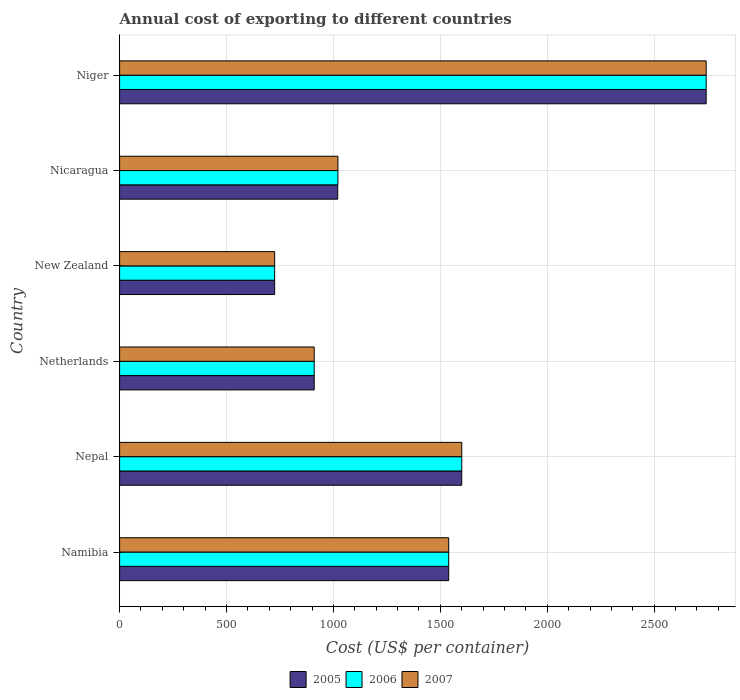How many groups of bars are there?
Your answer should be compact. 6. Are the number of bars per tick equal to the number of legend labels?
Keep it short and to the point. Yes. Are the number of bars on each tick of the Y-axis equal?
Offer a terse response. Yes. How many bars are there on the 4th tick from the bottom?
Offer a terse response. 3. What is the label of the 6th group of bars from the top?
Your answer should be very brief. Namibia. In how many cases, is the number of bars for a given country not equal to the number of legend labels?
Provide a succinct answer. 0. What is the total annual cost of exporting in 2006 in New Zealand?
Ensure brevity in your answer.  725. Across all countries, what is the maximum total annual cost of exporting in 2007?
Your answer should be compact. 2743. Across all countries, what is the minimum total annual cost of exporting in 2005?
Provide a succinct answer. 725. In which country was the total annual cost of exporting in 2006 maximum?
Offer a terse response. Niger. In which country was the total annual cost of exporting in 2007 minimum?
Your answer should be very brief. New Zealand. What is the total total annual cost of exporting in 2005 in the graph?
Give a very brief answer. 8537. What is the difference between the total annual cost of exporting in 2005 in Nepal and that in Nicaragua?
Your response must be concise. 580. What is the difference between the total annual cost of exporting in 2005 in Namibia and the total annual cost of exporting in 2007 in Niger?
Provide a short and direct response. -1204. What is the average total annual cost of exporting in 2005 per country?
Your answer should be very brief. 1422.83. What is the difference between the total annual cost of exporting in 2006 and total annual cost of exporting in 2007 in Nicaragua?
Your answer should be compact. 0. What is the ratio of the total annual cost of exporting in 2005 in New Zealand to that in Nicaragua?
Make the answer very short. 0.71. Is the total annual cost of exporting in 2007 in Nepal less than that in Netherlands?
Keep it short and to the point. No. Is the difference between the total annual cost of exporting in 2006 in Netherlands and Nicaragua greater than the difference between the total annual cost of exporting in 2007 in Netherlands and Nicaragua?
Your answer should be compact. No. What is the difference between the highest and the second highest total annual cost of exporting in 2006?
Keep it short and to the point. 1143. What is the difference between the highest and the lowest total annual cost of exporting in 2006?
Provide a succinct answer. 2018. In how many countries, is the total annual cost of exporting in 2005 greater than the average total annual cost of exporting in 2005 taken over all countries?
Keep it short and to the point. 3. What does the 3rd bar from the bottom in Niger represents?
Make the answer very short. 2007. Is it the case that in every country, the sum of the total annual cost of exporting in 2007 and total annual cost of exporting in 2005 is greater than the total annual cost of exporting in 2006?
Provide a short and direct response. Yes. How many bars are there?
Keep it short and to the point. 18. How many countries are there in the graph?
Give a very brief answer. 6. What is the difference between two consecutive major ticks on the X-axis?
Your answer should be very brief. 500. Does the graph contain any zero values?
Give a very brief answer. No. Where does the legend appear in the graph?
Make the answer very short. Bottom center. What is the title of the graph?
Make the answer very short. Annual cost of exporting to different countries. What is the label or title of the X-axis?
Offer a very short reply. Cost (US$ per container). What is the label or title of the Y-axis?
Ensure brevity in your answer.  Country. What is the Cost (US$ per container) in 2005 in Namibia?
Offer a very short reply. 1539. What is the Cost (US$ per container) in 2006 in Namibia?
Keep it short and to the point. 1539. What is the Cost (US$ per container) in 2007 in Namibia?
Your answer should be very brief. 1539. What is the Cost (US$ per container) of 2005 in Nepal?
Make the answer very short. 1600. What is the Cost (US$ per container) of 2006 in Nepal?
Your answer should be compact. 1600. What is the Cost (US$ per container) in 2007 in Nepal?
Your answer should be compact. 1600. What is the Cost (US$ per container) in 2005 in Netherlands?
Ensure brevity in your answer.  910. What is the Cost (US$ per container) in 2006 in Netherlands?
Keep it short and to the point. 910. What is the Cost (US$ per container) in 2007 in Netherlands?
Ensure brevity in your answer.  910. What is the Cost (US$ per container) in 2005 in New Zealand?
Your answer should be very brief. 725. What is the Cost (US$ per container) of 2006 in New Zealand?
Ensure brevity in your answer.  725. What is the Cost (US$ per container) of 2007 in New Zealand?
Your response must be concise. 725. What is the Cost (US$ per container) of 2005 in Nicaragua?
Give a very brief answer. 1020. What is the Cost (US$ per container) of 2006 in Nicaragua?
Offer a terse response. 1021. What is the Cost (US$ per container) in 2007 in Nicaragua?
Make the answer very short. 1021. What is the Cost (US$ per container) in 2005 in Niger?
Ensure brevity in your answer.  2743. What is the Cost (US$ per container) of 2006 in Niger?
Your answer should be very brief. 2743. What is the Cost (US$ per container) in 2007 in Niger?
Ensure brevity in your answer.  2743. Across all countries, what is the maximum Cost (US$ per container) in 2005?
Ensure brevity in your answer.  2743. Across all countries, what is the maximum Cost (US$ per container) in 2006?
Make the answer very short. 2743. Across all countries, what is the maximum Cost (US$ per container) in 2007?
Give a very brief answer. 2743. Across all countries, what is the minimum Cost (US$ per container) in 2005?
Your response must be concise. 725. Across all countries, what is the minimum Cost (US$ per container) in 2006?
Your answer should be very brief. 725. Across all countries, what is the minimum Cost (US$ per container) of 2007?
Make the answer very short. 725. What is the total Cost (US$ per container) in 2005 in the graph?
Offer a very short reply. 8537. What is the total Cost (US$ per container) in 2006 in the graph?
Keep it short and to the point. 8538. What is the total Cost (US$ per container) of 2007 in the graph?
Provide a succinct answer. 8538. What is the difference between the Cost (US$ per container) in 2005 in Namibia and that in Nepal?
Give a very brief answer. -61. What is the difference between the Cost (US$ per container) in 2006 in Namibia and that in Nepal?
Offer a very short reply. -61. What is the difference between the Cost (US$ per container) of 2007 in Namibia and that in Nepal?
Give a very brief answer. -61. What is the difference between the Cost (US$ per container) of 2005 in Namibia and that in Netherlands?
Provide a succinct answer. 629. What is the difference between the Cost (US$ per container) of 2006 in Namibia and that in Netherlands?
Make the answer very short. 629. What is the difference between the Cost (US$ per container) in 2007 in Namibia and that in Netherlands?
Make the answer very short. 629. What is the difference between the Cost (US$ per container) of 2005 in Namibia and that in New Zealand?
Your answer should be very brief. 814. What is the difference between the Cost (US$ per container) in 2006 in Namibia and that in New Zealand?
Offer a very short reply. 814. What is the difference between the Cost (US$ per container) in 2007 in Namibia and that in New Zealand?
Your answer should be compact. 814. What is the difference between the Cost (US$ per container) in 2005 in Namibia and that in Nicaragua?
Make the answer very short. 519. What is the difference between the Cost (US$ per container) in 2006 in Namibia and that in Nicaragua?
Give a very brief answer. 518. What is the difference between the Cost (US$ per container) of 2007 in Namibia and that in Nicaragua?
Offer a very short reply. 518. What is the difference between the Cost (US$ per container) in 2005 in Namibia and that in Niger?
Your response must be concise. -1204. What is the difference between the Cost (US$ per container) in 2006 in Namibia and that in Niger?
Keep it short and to the point. -1204. What is the difference between the Cost (US$ per container) of 2007 in Namibia and that in Niger?
Your answer should be compact. -1204. What is the difference between the Cost (US$ per container) of 2005 in Nepal and that in Netherlands?
Keep it short and to the point. 690. What is the difference between the Cost (US$ per container) in 2006 in Nepal and that in Netherlands?
Your answer should be compact. 690. What is the difference between the Cost (US$ per container) of 2007 in Nepal and that in Netherlands?
Give a very brief answer. 690. What is the difference between the Cost (US$ per container) of 2005 in Nepal and that in New Zealand?
Provide a succinct answer. 875. What is the difference between the Cost (US$ per container) in 2006 in Nepal and that in New Zealand?
Your answer should be very brief. 875. What is the difference between the Cost (US$ per container) of 2007 in Nepal and that in New Zealand?
Offer a terse response. 875. What is the difference between the Cost (US$ per container) of 2005 in Nepal and that in Nicaragua?
Offer a very short reply. 580. What is the difference between the Cost (US$ per container) of 2006 in Nepal and that in Nicaragua?
Offer a terse response. 579. What is the difference between the Cost (US$ per container) of 2007 in Nepal and that in Nicaragua?
Keep it short and to the point. 579. What is the difference between the Cost (US$ per container) of 2005 in Nepal and that in Niger?
Make the answer very short. -1143. What is the difference between the Cost (US$ per container) of 2006 in Nepal and that in Niger?
Offer a very short reply. -1143. What is the difference between the Cost (US$ per container) of 2007 in Nepal and that in Niger?
Your answer should be very brief. -1143. What is the difference between the Cost (US$ per container) of 2005 in Netherlands and that in New Zealand?
Offer a terse response. 185. What is the difference between the Cost (US$ per container) in 2006 in Netherlands and that in New Zealand?
Make the answer very short. 185. What is the difference between the Cost (US$ per container) of 2007 in Netherlands and that in New Zealand?
Make the answer very short. 185. What is the difference between the Cost (US$ per container) of 2005 in Netherlands and that in Nicaragua?
Ensure brevity in your answer.  -110. What is the difference between the Cost (US$ per container) of 2006 in Netherlands and that in Nicaragua?
Ensure brevity in your answer.  -111. What is the difference between the Cost (US$ per container) in 2007 in Netherlands and that in Nicaragua?
Your response must be concise. -111. What is the difference between the Cost (US$ per container) in 2005 in Netherlands and that in Niger?
Provide a short and direct response. -1833. What is the difference between the Cost (US$ per container) of 2006 in Netherlands and that in Niger?
Your answer should be very brief. -1833. What is the difference between the Cost (US$ per container) in 2007 in Netherlands and that in Niger?
Make the answer very short. -1833. What is the difference between the Cost (US$ per container) in 2005 in New Zealand and that in Nicaragua?
Provide a succinct answer. -295. What is the difference between the Cost (US$ per container) in 2006 in New Zealand and that in Nicaragua?
Offer a terse response. -296. What is the difference between the Cost (US$ per container) of 2007 in New Zealand and that in Nicaragua?
Provide a short and direct response. -296. What is the difference between the Cost (US$ per container) in 2005 in New Zealand and that in Niger?
Your answer should be compact. -2018. What is the difference between the Cost (US$ per container) of 2006 in New Zealand and that in Niger?
Your answer should be very brief. -2018. What is the difference between the Cost (US$ per container) in 2007 in New Zealand and that in Niger?
Keep it short and to the point. -2018. What is the difference between the Cost (US$ per container) in 2005 in Nicaragua and that in Niger?
Your response must be concise. -1723. What is the difference between the Cost (US$ per container) in 2006 in Nicaragua and that in Niger?
Your answer should be very brief. -1722. What is the difference between the Cost (US$ per container) of 2007 in Nicaragua and that in Niger?
Make the answer very short. -1722. What is the difference between the Cost (US$ per container) of 2005 in Namibia and the Cost (US$ per container) of 2006 in Nepal?
Keep it short and to the point. -61. What is the difference between the Cost (US$ per container) in 2005 in Namibia and the Cost (US$ per container) in 2007 in Nepal?
Offer a very short reply. -61. What is the difference between the Cost (US$ per container) of 2006 in Namibia and the Cost (US$ per container) of 2007 in Nepal?
Offer a terse response. -61. What is the difference between the Cost (US$ per container) of 2005 in Namibia and the Cost (US$ per container) of 2006 in Netherlands?
Offer a very short reply. 629. What is the difference between the Cost (US$ per container) of 2005 in Namibia and the Cost (US$ per container) of 2007 in Netherlands?
Make the answer very short. 629. What is the difference between the Cost (US$ per container) in 2006 in Namibia and the Cost (US$ per container) in 2007 in Netherlands?
Provide a short and direct response. 629. What is the difference between the Cost (US$ per container) of 2005 in Namibia and the Cost (US$ per container) of 2006 in New Zealand?
Your answer should be very brief. 814. What is the difference between the Cost (US$ per container) in 2005 in Namibia and the Cost (US$ per container) in 2007 in New Zealand?
Your answer should be compact. 814. What is the difference between the Cost (US$ per container) of 2006 in Namibia and the Cost (US$ per container) of 2007 in New Zealand?
Provide a succinct answer. 814. What is the difference between the Cost (US$ per container) of 2005 in Namibia and the Cost (US$ per container) of 2006 in Nicaragua?
Make the answer very short. 518. What is the difference between the Cost (US$ per container) of 2005 in Namibia and the Cost (US$ per container) of 2007 in Nicaragua?
Make the answer very short. 518. What is the difference between the Cost (US$ per container) of 2006 in Namibia and the Cost (US$ per container) of 2007 in Nicaragua?
Provide a succinct answer. 518. What is the difference between the Cost (US$ per container) in 2005 in Namibia and the Cost (US$ per container) in 2006 in Niger?
Provide a short and direct response. -1204. What is the difference between the Cost (US$ per container) in 2005 in Namibia and the Cost (US$ per container) in 2007 in Niger?
Your answer should be compact. -1204. What is the difference between the Cost (US$ per container) of 2006 in Namibia and the Cost (US$ per container) of 2007 in Niger?
Offer a terse response. -1204. What is the difference between the Cost (US$ per container) of 2005 in Nepal and the Cost (US$ per container) of 2006 in Netherlands?
Give a very brief answer. 690. What is the difference between the Cost (US$ per container) in 2005 in Nepal and the Cost (US$ per container) in 2007 in Netherlands?
Offer a very short reply. 690. What is the difference between the Cost (US$ per container) of 2006 in Nepal and the Cost (US$ per container) of 2007 in Netherlands?
Offer a terse response. 690. What is the difference between the Cost (US$ per container) in 2005 in Nepal and the Cost (US$ per container) in 2006 in New Zealand?
Give a very brief answer. 875. What is the difference between the Cost (US$ per container) in 2005 in Nepal and the Cost (US$ per container) in 2007 in New Zealand?
Make the answer very short. 875. What is the difference between the Cost (US$ per container) in 2006 in Nepal and the Cost (US$ per container) in 2007 in New Zealand?
Make the answer very short. 875. What is the difference between the Cost (US$ per container) of 2005 in Nepal and the Cost (US$ per container) of 2006 in Nicaragua?
Your answer should be compact. 579. What is the difference between the Cost (US$ per container) of 2005 in Nepal and the Cost (US$ per container) of 2007 in Nicaragua?
Provide a succinct answer. 579. What is the difference between the Cost (US$ per container) in 2006 in Nepal and the Cost (US$ per container) in 2007 in Nicaragua?
Provide a succinct answer. 579. What is the difference between the Cost (US$ per container) in 2005 in Nepal and the Cost (US$ per container) in 2006 in Niger?
Offer a very short reply. -1143. What is the difference between the Cost (US$ per container) in 2005 in Nepal and the Cost (US$ per container) in 2007 in Niger?
Provide a short and direct response. -1143. What is the difference between the Cost (US$ per container) of 2006 in Nepal and the Cost (US$ per container) of 2007 in Niger?
Your answer should be very brief. -1143. What is the difference between the Cost (US$ per container) in 2005 in Netherlands and the Cost (US$ per container) in 2006 in New Zealand?
Your response must be concise. 185. What is the difference between the Cost (US$ per container) in 2005 in Netherlands and the Cost (US$ per container) in 2007 in New Zealand?
Provide a succinct answer. 185. What is the difference between the Cost (US$ per container) in 2006 in Netherlands and the Cost (US$ per container) in 2007 in New Zealand?
Give a very brief answer. 185. What is the difference between the Cost (US$ per container) in 2005 in Netherlands and the Cost (US$ per container) in 2006 in Nicaragua?
Provide a short and direct response. -111. What is the difference between the Cost (US$ per container) of 2005 in Netherlands and the Cost (US$ per container) of 2007 in Nicaragua?
Keep it short and to the point. -111. What is the difference between the Cost (US$ per container) in 2006 in Netherlands and the Cost (US$ per container) in 2007 in Nicaragua?
Your answer should be very brief. -111. What is the difference between the Cost (US$ per container) of 2005 in Netherlands and the Cost (US$ per container) of 2006 in Niger?
Your response must be concise. -1833. What is the difference between the Cost (US$ per container) of 2005 in Netherlands and the Cost (US$ per container) of 2007 in Niger?
Provide a succinct answer. -1833. What is the difference between the Cost (US$ per container) of 2006 in Netherlands and the Cost (US$ per container) of 2007 in Niger?
Make the answer very short. -1833. What is the difference between the Cost (US$ per container) in 2005 in New Zealand and the Cost (US$ per container) in 2006 in Nicaragua?
Offer a terse response. -296. What is the difference between the Cost (US$ per container) of 2005 in New Zealand and the Cost (US$ per container) of 2007 in Nicaragua?
Offer a terse response. -296. What is the difference between the Cost (US$ per container) in 2006 in New Zealand and the Cost (US$ per container) in 2007 in Nicaragua?
Provide a short and direct response. -296. What is the difference between the Cost (US$ per container) of 2005 in New Zealand and the Cost (US$ per container) of 2006 in Niger?
Make the answer very short. -2018. What is the difference between the Cost (US$ per container) in 2005 in New Zealand and the Cost (US$ per container) in 2007 in Niger?
Make the answer very short. -2018. What is the difference between the Cost (US$ per container) in 2006 in New Zealand and the Cost (US$ per container) in 2007 in Niger?
Offer a very short reply. -2018. What is the difference between the Cost (US$ per container) in 2005 in Nicaragua and the Cost (US$ per container) in 2006 in Niger?
Provide a short and direct response. -1723. What is the difference between the Cost (US$ per container) in 2005 in Nicaragua and the Cost (US$ per container) in 2007 in Niger?
Ensure brevity in your answer.  -1723. What is the difference between the Cost (US$ per container) in 2006 in Nicaragua and the Cost (US$ per container) in 2007 in Niger?
Provide a succinct answer. -1722. What is the average Cost (US$ per container) in 2005 per country?
Ensure brevity in your answer.  1422.83. What is the average Cost (US$ per container) in 2006 per country?
Offer a very short reply. 1423. What is the average Cost (US$ per container) of 2007 per country?
Give a very brief answer. 1423. What is the difference between the Cost (US$ per container) in 2005 and Cost (US$ per container) in 2006 in Namibia?
Keep it short and to the point. 0. What is the difference between the Cost (US$ per container) of 2005 and Cost (US$ per container) of 2007 in Namibia?
Your response must be concise. 0. What is the difference between the Cost (US$ per container) of 2006 and Cost (US$ per container) of 2007 in Namibia?
Offer a terse response. 0. What is the difference between the Cost (US$ per container) in 2005 and Cost (US$ per container) in 2006 in Nepal?
Provide a short and direct response. 0. What is the difference between the Cost (US$ per container) of 2005 and Cost (US$ per container) of 2007 in Nepal?
Keep it short and to the point. 0. What is the difference between the Cost (US$ per container) of 2006 and Cost (US$ per container) of 2007 in Nepal?
Provide a succinct answer. 0. What is the difference between the Cost (US$ per container) in 2006 and Cost (US$ per container) in 2007 in Netherlands?
Your response must be concise. 0. What is the difference between the Cost (US$ per container) in 2006 and Cost (US$ per container) in 2007 in Niger?
Your answer should be compact. 0. What is the ratio of the Cost (US$ per container) of 2005 in Namibia to that in Nepal?
Keep it short and to the point. 0.96. What is the ratio of the Cost (US$ per container) in 2006 in Namibia to that in Nepal?
Ensure brevity in your answer.  0.96. What is the ratio of the Cost (US$ per container) in 2007 in Namibia to that in Nepal?
Keep it short and to the point. 0.96. What is the ratio of the Cost (US$ per container) in 2005 in Namibia to that in Netherlands?
Offer a very short reply. 1.69. What is the ratio of the Cost (US$ per container) of 2006 in Namibia to that in Netherlands?
Give a very brief answer. 1.69. What is the ratio of the Cost (US$ per container) in 2007 in Namibia to that in Netherlands?
Offer a terse response. 1.69. What is the ratio of the Cost (US$ per container) in 2005 in Namibia to that in New Zealand?
Give a very brief answer. 2.12. What is the ratio of the Cost (US$ per container) of 2006 in Namibia to that in New Zealand?
Make the answer very short. 2.12. What is the ratio of the Cost (US$ per container) in 2007 in Namibia to that in New Zealand?
Your response must be concise. 2.12. What is the ratio of the Cost (US$ per container) in 2005 in Namibia to that in Nicaragua?
Give a very brief answer. 1.51. What is the ratio of the Cost (US$ per container) of 2006 in Namibia to that in Nicaragua?
Keep it short and to the point. 1.51. What is the ratio of the Cost (US$ per container) of 2007 in Namibia to that in Nicaragua?
Keep it short and to the point. 1.51. What is the ratio of the Cost (US$ per container) of 2005 in Namibia to that in Niger?
Your response must be concise. 0.56. What is the ratio of the Cost (US$ per container) of 2006 in Namibia to that in Niger?
Ensure brevity in your answer.  0.56. What is the ratio of the Cost (US$ per container) in 2007 in Namibia to that in Niger?
Provide a short and direct response. 0.56. What is the ratio of the Cost (US$ per container) of 2005 in Nepal to that in Netherlands?
Ensure brevity in your answer.  1.76. What is the ratio of the Cost (US$ per container) of 2006 in Nepal to that in Netherlands?
Your answer should be very brief. 1.76. What is the ratio of the Cost (US$ per container) in 2007 in Nepal to that in Netherlands?
Your answer should be very brief. 1.76. What is the ratio of the Cost (US$ per container) in 2005 in Nepal to that in New Zealand?
Offer a terse response. 2.21. What is the ratio of the Cost (US$ per container) in 2006 in Nepal to that in New Zealand?
Offer a very short reply. 2.21. What is the ratio of the Cost (US$ per container) of 2007 in Nepal to that in New Zealand?
Give a very brief answer. 2.21. What is the ratio of the Cost (US$ per container) of 2005 in Nepal to that in Nicaragua?
Provide a succinct answer. 1.57. What is the ratio of the Cost (US$ per container) of 2006 in Nepal to that in Nicaragua?
Provide a succinct answer. 1.57. What is the ratio of the Cost (US$ per container) in 2007 in Nepal to that in Nicaragua?
Offer a very short reply. 1.57. What is the ratio of the Cost (US$ per container) in 2005 in Nepal to that in Niger?
Provide a succinct answer. 0.58. What is the ratio of the Cost (US$ per container) of 2006 in Nepal to that in Niger?
Your response must be concise. 0.58. What is the ratio of the Cost (US$ per container) of 2007 in Nepal to that in Niger?
Your response must be concise. 0.58. What is the ratio of the Cost (US$ per container) in 2005 in Netherlands to that in New Zealand?
Your answer should be compact. 1.26. What is the ratio of the Cost (US$ per container) of 2006 in Netherlands to that in New Zealand?
Ensure brevity in your answer.  1.26. What is the ratio of the Cost (US$ per container) of 2007 in Netherlands to that in New Zealand?
Ensure brevity in your answer.  1.26. What is the ratio of the Cost (US$ per container) of 2005 in Netherlands to that in Nicaragua?
Your answer should be very brief. 0.89. What is the ratio of the Cost (US$ per container) in 2006 in Netherlands to that in Nicaragua?
Your answer should be compact. 0.89. What is the ratio of the Cost (US$ per container) of 2007 in Netherlands to that in Nicaragua?
Make the answer very short. 0.89. What is the ratio of the Cost (US$ per container) of 2005 in Netherlands to that in Niger?
Make the answer very short. 0.33. What is the ratio of the Cost (US$ per container) of 2006 in Netherlands to that in Niger?
Your answer should be very brief. 0.33. What is the ratio of the Cost (US$ per container) of 2007 in Netherlands to that in Niger?
Your response must be concise. 0.33. What is the ratio of the Cost (US$ per container) of 2005 in New Zealand to that in Nicaragua?
Give a very brief answer. 0.71. What is the ratio of the Cost (US$ per container) in 2006 in New Zealand to that in Nicaragua?
Provide a short and direct response. 0.71. What is the ratio of the Cost (US$ per container) in 2007 in New Zealand to that in Nicaragua?
Provide a short and direct response. 0.71. What is the ratio of the Cost (US$ per container) in 2005 in New Zealand to that in Niger?
Your answer should be compact. 0.26. What is the ratio of the Cost (US$ per container) in 2006 in New Zealand to that in Niger?
Ensure brevity in your answer.  0.26. What is the ratio of the Cost (US$ per container) of 2007 in New Zealand to that in Niger?
Provide a short and direct response. 0.26. What is the ratio of the Cost (US$ per container) of 2005 in Nicaragua to that in Niger?
Offer a terse response. 0.37. What is the ratio of the Cost (US$ per container) in 2006 in Nicaragua to that in Niger?
Provide a short and direct response. 0.37. What is the ratio of the Cost (US$ per container) of 2007 in Nicaragua to that in Niger?
Your answer should be compact. 0.37. What is the difference between the highest and the second highest Cost (US$ per container) in 2005?
Keep it short and to the point. 1143. What is the difference between the highest and the second highest Cost (US$ per container) of 2006?
Your answer should be very brief. 1143. What is the difference between the highest and the second highest Cost (US$ per container) of 2007?
Offer a terse response. 1143. What is the difference between the highest and the lowest Cost (US$ per container) in 2005?
Keep it short and to the point. 2018. What is the difference between the highest and the lowest Cost (US$ per container) in 2006?
Keep it short and to the point. 2018. What is the difference between the highest and the lowest Cost (US$ per container) of 2007?
Your answer should be very brief. 2018. 